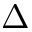<formula> <loc_0><loc_0><loc_500><loc_500>\Delta</formula> 